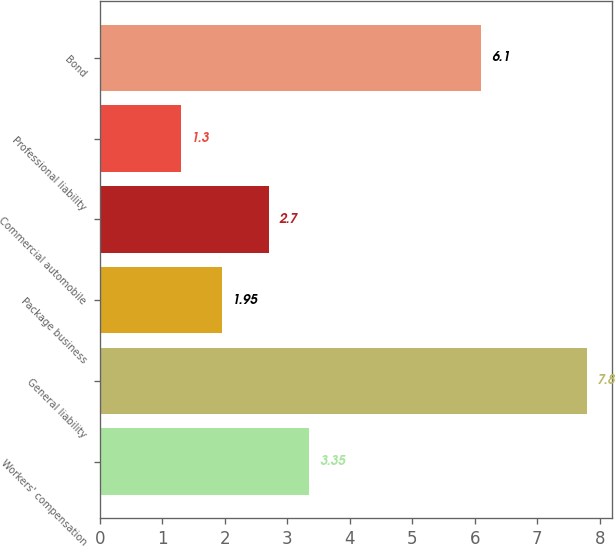Convert chart. <chart><loc_0><loc_0><loc_500><loc_500><bar_chart><fcel>Workers' compensation<fcel>General liability<fcel>Package business<fcel>Commercial automobile<fcel>Professional liability<fcel>Bond<nl><fcel>3.35<fcel>7.8<fcel>1.95<fcel>2.7<fcel>1.3<fcel>6.1<nl></chart> 